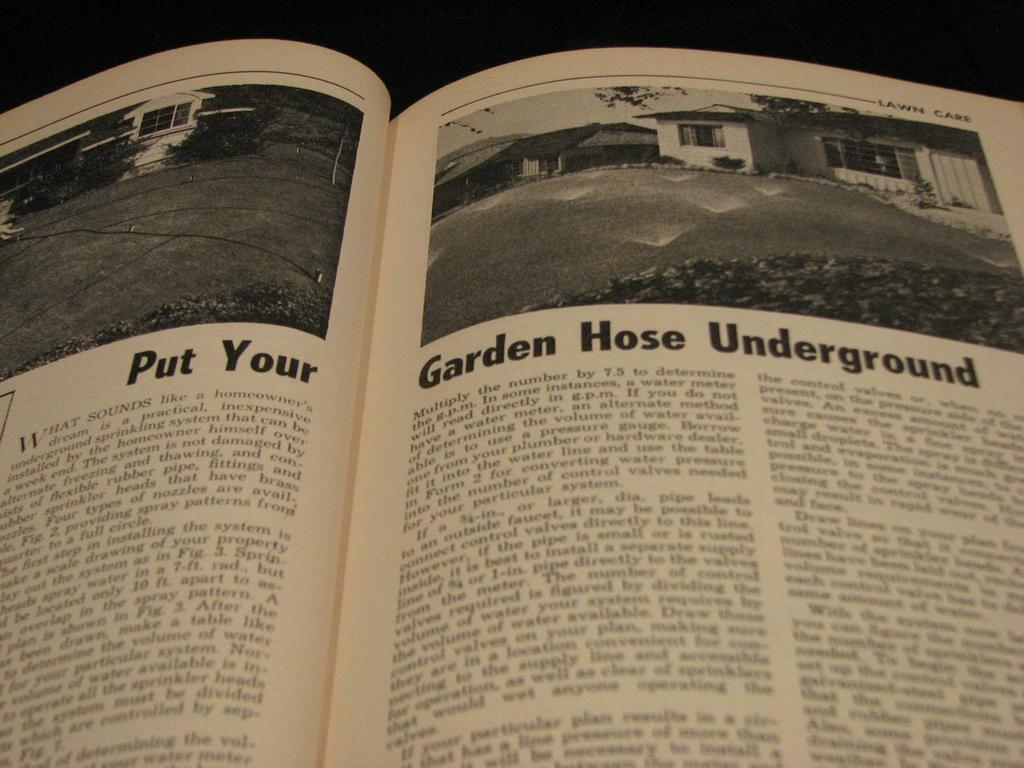<image>
Present a compact description of the photo's key features. A book open to a with the title Put Your Garden Hose Underground. 